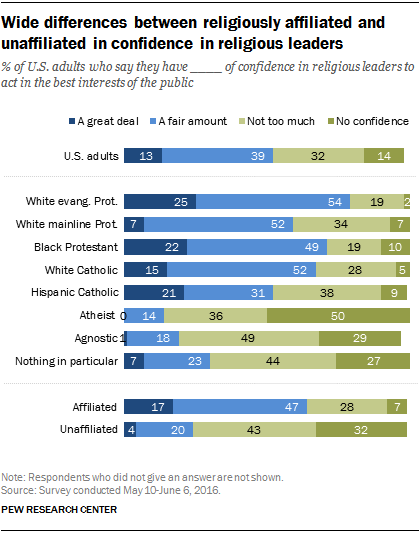Give some essential details in this illustration. The value of the smallest light green bar is 19. Please provide the average of the smallest green bar and the first light blue bar from the top, rounded to two decimal places. 